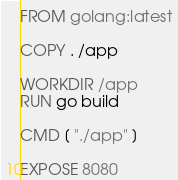Convert code to text. <code><loc_0><loc_0><loc_500><loc_500><_Dockerfile_>FROM golang:latest

COPY . /app

WORKDIR /app
RUN go build

CMD [ "./app" ]

EXPOSE 8080
</code> 